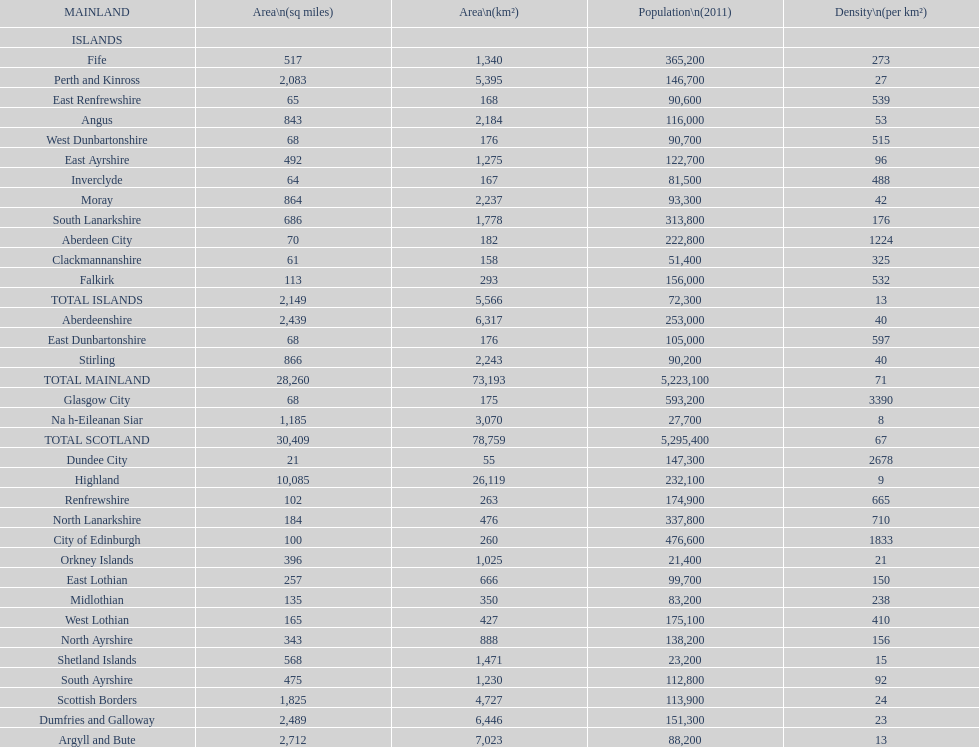What number of mainlands have populations under 100,000? 9. 